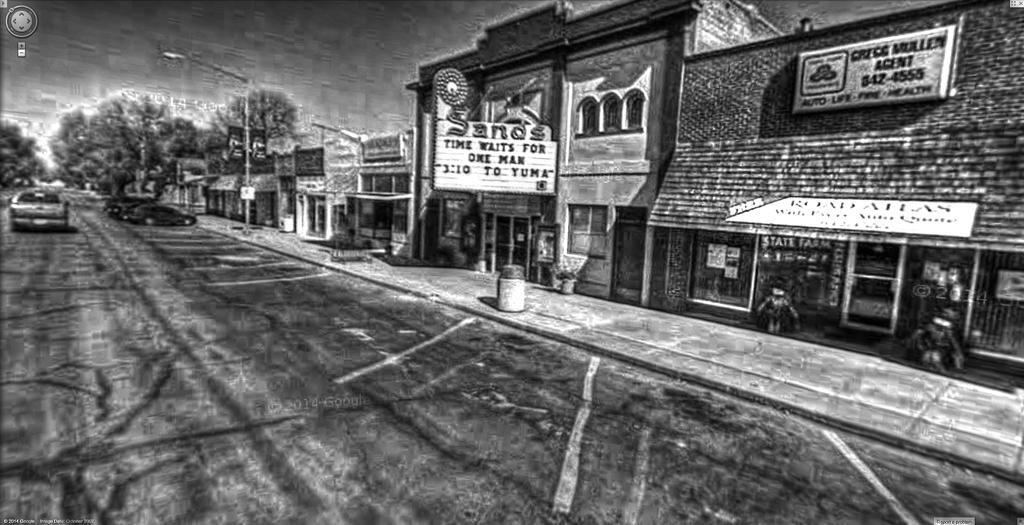What does the sign say time waits for?
Your answer should be very brief. One man. What is playing at the theater?
Keep it short and to the point. Time waits for one man. 